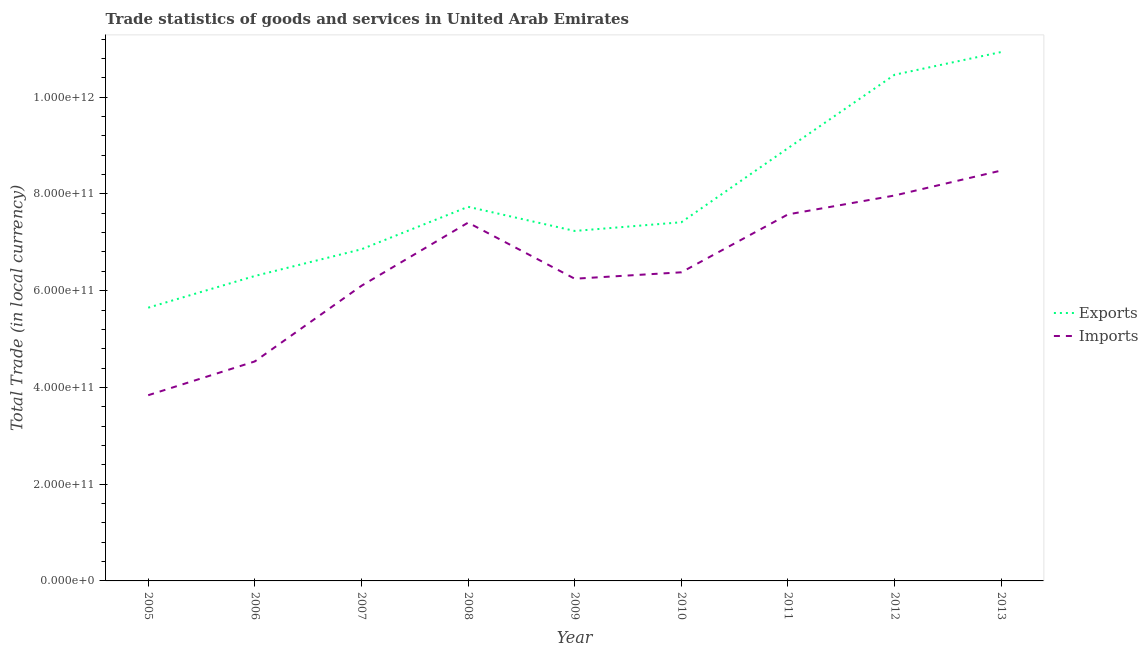What is the export of goods and services in 2005?
Offer a terse response. 5.65e+11. Across all years, what is the maximum imports of goods and services?
Provide a short and direct response. 8.48e+11. Across all years, what is the minimum export of goods and services?
Provide a short and direct response. 5.65e+11. In which year was the imports of goods and services maximum?
Provide a succinct answer. 2013. What is the total export of goods and services in the graph?
Your answer should be very brief. 7.15e+12. What is the difference between the imports of goods and services in 2010 and that in 2011?
Give a very brief answer. -1.20e+11. What is the difference between the imports of goods and services in 2013 and the export of goods and services in 2008?
Keep it short and to the point. 7.50e+1. What is the average export of goods and services per year?
Offer a terse response. 7.95e+11. In the year 2008, what is the difference between the imports of goods and services and export of goods and services?
Ensure brevity in your answer.  -3.27e+1. In how many years, is the imports of goods and services greater than 1080000000000 LCU?
Your response must be concise. 0. What is the ratio of the imports of goods and services in 2005 to that in 2008?
Provide a succinct answer. 0.52. What is the difference between the highest and the second highest imports of goods and services?
Provide a succinct answer. 5.16e+1. What is the difference between the highest and the lowest export of goods and services?
Make the answer very short. 5.29e+11. In how many years, is the imports of goods and services greater than the average imports of goods and services taken over all years?
Your response must be concise. 4. Is the imports of goods and services strictly less than the export of goods and services over the years?
Your answer should be very brief. Yes. How many lines are there?
Your answer should be very brief. 2. What is the difference between two consecutive major ticks on the Y-axis?
Offer a very short reply. 2.00e+11. Are the values on the major ticks of Y-axis written in scientific E-notation?
Ensure brevity in your answer.  Yes. Does the graph contain grids?
Provide a succinct answer. No. Where does the legend appear in the graph?
Ensure brevity in your answer.  Center right. What is the title of the graph?
Provide a succinct answer. Trade statistics of goods and services in United Arab Emirates. What is the label or title of the Y-axis?
Your response must be concise. Total Trade (in local currency). What is the Total Trade (in local currency) of Exports in 2005?
Offer a terse response. 5.65e+11. What is the Total Trade (in local currency) of Imports in 2005?
Your answer should be very brief. 3.84e+11. What is the Total Trade (in local currency) of Exports in 2006?
Provide a succinct answer. 6.30e+11. What is the Total Trade (in local currency) of Imports in 2006?
Your answer should be compact. 4.54e+11. What is the Total Trade (in local currency) of Exports in 2007?
Your answer should be compact. 6.86e+11. What is the Total Trade (in local currency) of Imports in 2007?
Provide a short and direct response. 6.10e+11. What is the Total Trade (in local currency) in Exports in 2008?
Offer a very short reply. 7.73e+11. What is the Total Trade (in local currency) in Imports in 2008?
Give a very brief answer. 7.41e+11. What is the Total Trade (in local currency) in Exports in 2009?
Provide a short and direct response. 7.24e+11. What is the Total Trade (in local currency) in Imports in 2009?
Offer a very short reply. 6.25e+11. What is the Total Trade (in local currency) of Exports in 2010?
Keep it short and to the point. 7.41e+11. What is the Total Trade (in local currency) in Imports in 2010?
Provide a short and direct response. 6.38e+11. What is the Total Trade (in local currency) in Exports in 2011?
Your answer should be very brief. 8.95e+11. What is the Total Trade (in local currency) of Imports in 2011?
Provide a succinct answer. 7.58e+11. What is the Total Trade (in local currency) in Exports in 2012?
Make the answer very short. 1.05e+12. What is the Total Trade (in local currency) in Imports in 2012?
Offer a very short reply. 7.97e+11. What is the Total Trade (in local currency) of Exports in 2013?
Provide a short and direct response. 1.09e+12. What is the Total Trade (in local currency) of Imports in 2013?
Give a very brief answer. 8.48e+11. Across all years, what is the maximum Total Trade (in local currency) of Exports?
Make the answer very short. 1.09e+12. Across all years, what is the maximum Total Trade (in local currency) in Imports?
Ensure brevity in your answer.  8.48e+11. Across all years, what is the minimum Total Trade (in local currency) of Exports?
Your response must be concise. 5.65e+11. Across all years, what is the minimum Total Trade (in local currency) in Imports?
Your answer should be compact. 3.84e+11. What is the total Total Trade (in local currency) in Exports in the graph?
Keep it short and to the point. 7.15e+12. What is the total Total Trade (in local currency) of Imports in the graph?
Provide a short and direct response. 5.85e+12. What is the difference between the Total Trade (in local currency) in Exports in 2005 and that in 2006?
Your response must be concise. -6.56e+1. What is the difference between the Total Trade (in local currency) in Imports in 2005 and that in 2006?
Make the answer very short. -6.99e+1. What is the difference between the Total Trade (in local currency) of Exports in 2005 and that in 2007?
Your answer should be compact. -1.21e+11. What is the difference between the Total Trade (in local currency) of Imports in 2005 and that in 2007?
Keep it short and to the point. -2.26e+11. What is the difference between the Total Trade (in local currency) of Exports in 2005 and that in 2008?
Offer a terse response. -2.09e+11. What is the difference between the Total Trade (in local currency) in Imports in 2005 and that in 2008?
Offer a very short reply. -3.57e+11. What is the difference between the Total Trade (in local currency) of Exports in 2005 and that in 2009?
Your response must be concise. -1.59e+11. What is the difference between the Total Trade (in local currency) in Imports in 2005 and that in 2009?
Offer a very short reply. -2.41e+11. What is the difference between the Total Trade (in local currency) of Exports in 2005 and that in 2010?
Provide a succinct answer. -1.77e+11. What is the difference between the Total Trade (in local currency) in Imports in 2005 and that in 2010?
Your response must be concise. -2.54e+11. What is the difference between the Total Trade (in local currency) in Exports in 2005 and that in 2011?
Give a very brief answer. -3.30e+11. What is the difference between the Total Trade (in local currency) in Imports in 2005 and that in 2011?
Your answer should be very brief. -3.74e+11. What is the difference between the Total Trade (in local currency) of Exports in 2005 and that in 2012?
Keep it short and to the point. -4.82e+11. What is the difference between the Total Trade (in local currency) of Imports in 2005 and that in 2012?
Your response must be concise. -4.13e+11. What is the difference between the Total Trade (in local currency) in Exports in 2005 and that in 2013?
Offer a very short reply. -5.29e+11. What is the difference between the Total Trade (in local currency) in Imports in 2005 and that in 2013?
Provide a succinct answer. -4.64e+11. What is the difference between the Total Trade (in local currency) in Exports in 2006 and that in 2007?
Ensure brevity in your answer.  -5.52e+1. What is the difference between the Total Trade (in local currency) in Imports in 2006 and that in 2007?
Your response must be concise. -1.56e+11. What is the difference between the Total Trade (in local currency) of Exports in 2006 and that in 2008?
Your answer should be compact. -1.43e+11. What is the difference between the Total Trade (in local currency) of Imports in 2006 and that in 2008?
Ensure brevity in your answer.  -2.87e+11. What is the difference between the Total Trade (in local currency) of Exports in 2006 and that in 2009?
Make the answer very short. -9.31e+1. What is the difference between the Total Trade (in local currency) in Imports in 2006 and that in 2009?
Your response must be concise. -1.71e+11. What is the difference between the Total Trade (in local currency) in Exports in 2006 and that in 2010?
Make the answer very short. -1.11e+11. What is the difference between the Total Trade (in local currency) in Imports in 2006 and that in 2010?
Offer a very short reply. -1.84e+11. What is the difference between the Total Trade (in local currency) in Exports in 2006 and that in 2011?
Your response must be concise. -2.64e+11. What is the difference between the Total Trade (in local currency) of Imports in 2006 and that in 2011?
Your answer should be very brief. -3.04e+11. What is the difference between the Total Trade (in local currency) of Exports in 2006 and that in 2012?
Your response must be concise. -4.16e+11. What is the difference between the Total Trade (in local currency) of Imports in 2006 and that in 2012?
Provide a short and direct response. -3.43e+11. What is the difference between the Total Trade (in local currency) of Exports in 2006 and that in 2013?
Make the answer very short. -4.63e+11. What is the difference between the Total Trade (in local currency) in Imports in 2006 and that in 2013?
Your answer should be very brief. -3.95e+11. What is the difference between the Total Trade (in local currency) in Exports in 2007 and that in 2008?
Give a very brief answer. -8.78e+1. What is the difference between the Total Trade (in local currency) in Imports in 2007 and that in 2008?
Your answer should be very brief. -1.31e+11. What is the difference between the Total Trade (in local currency) in Exports in 2007 and that in 2009?
Offer a very short reply. -3.79e+1. What is the difference between the Total Trade (in local currency) in Imports in 2007 and that in 2009?
Your response must be concise. -1.46e+1. What is the difference between the Total Trade (in local currency) of Exports in 2007 and that in 2010?
Ensure brevity in your answer.  -5.59e+1. What is the difference between the Total Trade (in local currency) of Imports in 2007 and that in 2010?
Keep it short and to the point. -2.79e+1. What is the difference between the Total Trade (in local currency) of Exports in 2007 and that in 2011?
Ensure brevity in your answer.  -2.09e+11. What is the difference between the Total Trade (in local currency) in Imports in 2007 and that in 2011?
Provide a succinct answer. -1.48e+11. What is the difference between the Total Trade (in local currency) of Exports in 2007 and that in 2012?
Ensure brevity in your answer.  -3.61e+11. What is the difference between the Total Trade (in local currency) of Imports in 2007 and that in 2012?
Keep it short and to the point. -1.87e+11. What is the difference between the Total Trade (in local currency) in Exports in 2007 and that in 2013?
Ensure brevity in your answer.  -4.08e+11. What is the difference between the Total Trade (in local currency) of Imports in 2007 and that in 2013?
Provide a short and direct response. -2.38e+11. What is the difference between the Total Trade (in local currency) of Exports in 2008 and that in 2009?
Ensure brevity in your answer.  4.99e+1. What is the difference between the Total Trade (in local currency) of Imports in 2008 and that in 2009?
Ensure brevity in your answer.  1.16e+11. What is the difference between the Total Trade (in local currency) of Exports in 2008 and that in 2010?
Offer a very short reply. 3.19e+1. What is the difference between the Total Trade (in local currency) of Imports in 2008 and that in 2010?
Provide a short and direct response. 1.03e+11. What is the difference between the Total Trade (in local currency) of Exports in 2008 and that in 2011?
Give a very brief answer. -1.21e+11. What is the difference between the Total Trade (in local currency) of Imports in 2008 and that in 2011?
Your answer should be compact. -1.70e+1. What is the difference between the Total Trade (in local currency) of Exports in 2008 and that in 2012?
Keep it short and to the point. -2.73e+11. What is the difference between the Total Trade (in local currency) in Imports in 2008 and that in 2012?
Provide a succinct answer. -5.61e+1. What is the difference between the Total Trade (in local currency) of Exports in 2008 and that in 2013?
Keep it short and to the point. -3.20e+11. What is the difference between the Total Trade (in local currency) in Imports in 2008 and that in 2013?
Your answer should be very brief. -1.08e+11. What is the difference between the Total Trade (in local currency) of Exports in 2009 and that in 2010?
Make the answer very short. -1.80e+1. What is the difference between the Total Trade (in local currency) in Imports in 2009 and that in 2010?
Make the answer very short. -1.33e+1. What is the difference between the Total Trade (in local currency) in Exports in 2009 and that in 2011?
Provide a short and direct response. -1.71e+11. What is the difference between the Total Trade (in local currency) of Imports in 2009 and that in 2011?
Give a very brief answer. -1.33e+11. What is the difference between the Total Trade (in local currency) in Exports in 2009 and that in 2012?
Your answer should be very brief. -3.23e+11. What is the difference between the Total Trade (in local currency) in Imports in 2009 and that in 2012?
Make the answer very short. -1.72e+11. What is the difference between the Total Trade (in local currency) in Exports in 2009 and that in 2013?
Your answer should be compact. -3.70e+11. What is the difference between the Total Trade (in local currency) in Imports in 2009 and that in 2013?
Your answer should be very brief. -2.24e+11. What is the difference between the Total Trade (in local currency) of Exports in 2010 and that in 2011?
Your answer should be compact. -1.53e+11. What is the difference between the Total Trade (in local currency) in Imports in 2010 and that in 2011?
Provide a short and direct response. -1.20e+11. What is the difference between the Total Trade (in local currency) in Exports in 2010 and that in 2012?
Provide a short and direct response. -3.05e+11. What is the difference between the Total Trade (in local currency) of Imports in 2010 and that in 2012?
Give a very brief answer. -1.59e+11. What is the difference between the Total Trade (in local currency) in Exports in 2010 and that in 2013?
Provide a succinct answer. -3.52e+11. What is the difference between the Total Trade (in local currency) in Imports in 2010 and that in 2013?
Make the answer very short. -2.10e+11. What is the difference between the Total Trade (in local currency) of Exports in 2011 and that in 2012?
Provide a succinct answer. -1.52e+11. What is the difference between the Total Trade (in local currency) in Imports in 2011 and that in 2012?
Ensure brevity in your answer.  -3.91e+1. What is the difference between the Total Trade (in local currency) of Exports in 2011 and that in 2013?
Provide a short and direct response. -1.99e+11. What is the difference between the Total Trade (in local currency) in Imports in 2011 and that in 2013?
Your answer should be very brief. -9.07e+1. What is the difference between the Total Trade (in local currency) in Exports in 2012 and that in 2013?
Give a very brief answer. -4.69e+1. What is the difference between the Total Trade (in local currency) in Imports in 2012 and that in 2013?
Keep it short and to the point. -5.16e+1. What is the difference between the Total Trade (in local currency) of Exports in 2005 and the Total Trade (in local currency) of Imports in 2006?
Provide a short and direct response. 1.11e+11. What is the difference between the Total Trade (in local currency) in Exports in 2005 and the Total Trade (in local currency) in Imports in 2007?
Offer a very short reply. -4.53e+1. What is the difference between the Total Trade (in local currency) of Exports in 2005 and the Total Trade (in local currency) of Imports in 2008?
Keep it short and to the point. -1.76e+11. What is the difference between the Total Trade (in local currency) in Exports in 2005 and the Total Trade (in local currency) in Imports in 2009?
Make the answer very short. -5.99e+1. What is the difference between the Total Trade (in local currency) in Exports in 2005 and the Total Trade (in local currency) in Imports in 2010?
Your answer should be very brief. -7.32e+1. What is the difference between the Total Trade (in local currency) of Exports in 2005 and the Total Trade (in local currency) of Imports in 2011?
Make the answer very short. -1.93e+11. What is the difference between the Total Trade (in local currency) in Exports in 2005 and the Total Trade (in local currency) in Imports in 2012?
Your answer should be compact. -2.32e+11. What is the difference between the Total Trade (in local currency) in Exports in 2005 and the Total Trade (in local currency) in Imports in 2013?
Provide a short and direct response. -2.84e+11. What is the difference between the Total Trade (in local currency) in Exports in 2006 and the Total Trade (in local currency) in Imports in 2007?
Your answer should be compact. 2.03e+1. What is the difference between the Total Trade (in local currency) of Exports in 2006 and the Total Trade (in local currency) of Imports in 2008?
Your answer should be very brief. -1.10e+11. What is the difference between the Total Trade (in local currency) in Exports in 2006 and the Total Trade (in local currency) in Imports in 2009?
Your response must be concise. 5.67e+09. What is the difference between the Total Trade (in local currency) of Exports in 2006 and the Total Trade (in local currency) of Imports in 2010?
Offer a very short reply. -7.59e+09. What is the difference between the Total Trade (in local currency) in Exports in 2006 and the Total Trade (in local currency) in Imports in 2011?
Keep it short and to the point. -1.27e+11. What is the difference between the Total Trade (in local currency) in Exports in 2006 and the Total Trade (in local currency) in Imports in 2012?
Give a very brief answer. -1.66e+11. What is the difference between the Total Trade (in local currency) of Exports in 2006 and the Total Trade (in local currency) of Imports in 2013?
Your answer should be very brief. -2.18e+11. What is the difference between the Total Trade (in local currency) of Exports in 2007 and the Total Trade (in local currency) of Imports in 2008?
Offer a terse response. -5.51e+1. What is the difference between the Total Trade (in local currency) in Exports in 2007 and the Total Trade (in local currency) in Imports in 2009?
Provide a succinct answer. 6.09e+1. What is the difference between the Total Trade (in local currency) of Exports in 2007 and the Total Trade (in local currency) of Imports in 2010?
Your answer should be very brief. 4.76e+1. What is the difference between the Total Trade (in local currency) in Exports in 2007 and the Total Trade (in local currency) in Imports in 2011?
Your answer should be very brief. -7.21e+1. What is the difference between the Total Trade (in local currency) in Exports in 2007 and the Total Trade (in local currency) in Imports in 2012?
Give a very brief answer. -1.11e+11. What is the difference between the Total Trade (in local currency) in Exports in 2007 and the Total Trade (in local currency) in Imports in 2013?
Keep it short and to the point. -1.63e+11. What is the difference between the Total Trade (in local currency) in Exports in 2008 and the Total Trade (in local currency) in Imports in 2009?
Your answer should be very brief. 1.49e+11. What is the difference between the Total Trade (in local currency) of Exports in 2008 and the Total Trade (in local currency) of Imports in 2010?
Your response must be concise. 1.35e+11. What is the difference between the Total Trade (in local currency) in Exports in 2008 and the Total Trade (in local currency) in Imports in 2011?
Your response must be concise. 1.57e+1. What is the difference between the Total Trade (in local currency) in Exports in 2008 and the Total Trade (in local currency) in Imports in 2012?
Your response must be concise. -2.34e+1. What is the difference between the Total Trade (in local currency) in Exports in 2008 and the Total Trade (in local currency) in Imports in 2013?
Ensure brevity in your answer.  -7.50e+1. What is the difference between the Total Trade (in local currency) of Exports in 2009 and the Total Trade (in local currency) of Imports in 2010?
Keep it short and to the point. 8.55e+1. What is the difference between the Total Trade (in local currency) in Exports in 2009 and the Total Trade (in local currency) in Imports in 2011?
Your answer should be very brief. -3.42e+1. What is the difference between the Total Trade (in local currency) of Exports in 2009 and the Total Trade (in local currency) of Imports in 2012?
Offer a very short reply. -7.33e+1. What is the difference between the Total Trade (in local currency) in Exports in 2009 and the Total Trade (in local currency) in Imports in 2013?
Your answer should be compact. -1.25e+11. What is the difference between the Total Trade (in local currency) in Exports in 2010 and the Total Trade (in local currency) in Imports in 2011?
Your response must be concise. -1.62e+1. What is the difference between the Total Trade (in local currency) of Exports in 2010 and the Total Trade (in local currency) of Imports in 2012?
Give a very brief answer. -5.53e+1. What is the difference between the Total Trade (in local currency) of Exports in 2010 and the Total Trade (in local currency) of Imports in 2013?
Give a very brief answer. -1.07e+11. What is the difference between the Total Trade (in local currency) in Exports in 2011 and the Total Trade (in local currency) in Imports in 2012?
Your answer should be compact. 9.78e+1. What is the difference between the Total Trade (in local currency) of Exports in 2011 and the Total Trade (in local currency) of Imports in 2013?
Provide a succinct answer. 4.63e+1. What is the difference between the Total Trade (in local currency) of Exports in 2012 and the Total Trade (in local currency) of Imports in 2013?
Keep it short and to the point. 1.98e+11. What is the average Total Trade (in local currency) in Exports per year?
Make the answer very short. 7.95e+11. What is the average Total Trade (in local currency) of Imports per year?
Provide a short and direct response. 6.50e+11. In the year 2005, what is the difference between the Total Trade (in local currency) in Exports and Total Trade (in local currency) in Imports?
Give a very brief answer. 1.81e+11. In the year 2006, what is the difference between the Total Trade (in local currency) of Exports and Total Trade (in local currency) of Imports?
Provide a short and direct response. 1.77e+11. In the year 2007, what is the difference between the Total Trade (in local currency) in Exports and Total Trade (in local currency) in Imports?
Give a very brief answer. 7.55e+1. In the year 2008, what is the difference between the Total Trade (in local currency) in Exports and Total Trade (in local currency) in Imports?
Your answer should be very brief. 3.27e+1. In the year 2009, what is the difference between the Total Trade (in local currency) of Exports and Total Trade (in local currency) of Imports?
Your answer should be compact. 9.88e+1. In the year 2010, what is the difference between the Total Trade (in local currency) of Exports and Total Trade (in local currency) of Imports?
Give a very brief answer. 1.03e+11. In the year 2011, what is the difference between the Total Trade (in local currency) in Exports and Total Trade (in local currency) in Imports?
Your answer should be compact. 1.37e+11. In the year 2012, what is the difference between the Total Trade (in local currency) in Exports and Total Trade (in local currency) in Imports?
Ensure brevity in your answer.  2.50e+11. In the year 2013, what is the difference between the Total Trade (in local currency) in Exports and Total Trade (in local currency) in Imports?
Your response must be concise. 2.45e+11. What is the ratio of the Total Trade (in local currency) of Exports in 2005 to that in 2006?
Keep it short and to the point. 0.9. What is the ratio of the Total Trade (in local currency) in Imports in 2005 to that in 2006?
Give a very brief answer. 0.85. What is the ratio of the Total Trade (in local currency) in Exports in 2005 to that in 2007?
Give a very brief answer. 0.82. What is the ratio of the Total Trade (in local currency) of Imports in 2005 to that in 2007?
Your response must be concise. 0.63. What is the ratio of the Total Trade (in local currency) of Exports in 2005 to that in 2008?
Your response must be concise. 0.73. What is the ratio of the Total Trade (in local currency) of Imports in 2005 to that in 2008?
Make the answer very short. 0.52. What is the ratio of the Total Trade (in local currency) of Exports in 2005 to that in 2009?
Provide a succinct answer. 0.78. What is the ratio of the Total Trade (in local currency) in Imports in 2005 to that in 2009?
Your answer should be very brief. 0.61. What is the ratio of the Total Trade (in local currency) of Exports in 2005 to that in 2010?
Keep it short and to the point. 0.76. What is the ratio of the Total Trade (in local currency) of Imports in 2005 to that in 2010?
Give a very brief answer. 0.6. What is the ratio of the Total Trade (in local currency) in Exports in 2005 to that in 2011?
Your answer should be compact. 0.63. What is the ratio of the Total Trade (in local currency) in Imports in 2005 to that in 2011?
Provide a succinct answer. 0.51. What is the ratio of the Total Trade (in local currency) of Exports in 2005 to that in 2012?
Ensure brevity in your answer.  0.54. What is the ratio of the Total Trade (in local currency) in Imports in 2005 to that in 2012?
Provide a succinct answer. 0.48. What is the ratio of the Total Trade (in local currency) in Exports in 2005 to that in 2013?
Your response must be concise. 0.52. What is the ratio of the Total Trade (in local currency) in Imports in 2005 to that in 2013?
Your answer should be compact. 0.45. What is the ratio of the Total Trade (in local currency) in Exports in 2006 to that in 2007?
Make the answer very short. 0.92. What is the ratio of the Total Trade (in local currency) of Imports in 2006 to that in 2007?
Your response must be concise. 0.74. What is the ratio of the Total Trade (in local currency) in Exports in 2006 to that in 2008?
Offer a terse response. 0.82. What is the ratio of the Total Trade (in local currency) of Imports in 2006 to that in 2008?
Your response must be concise. 0.61. What is the ratio of the Total Trade (in local currency) of Exports in 2006 to that in 2009?
Provide a succinct answer. 0.87. What is the ratio of the Total Trade (in local currency) in Imports in 2006 to that in 2009?
Offer a terse response. 0.73. What is the ratio of the Total Trade (in local currency) of Exports in 2006 to that in 2010?
Provide a succinct answer. 0.85. What is the ratio of the Total Trade (in local currency) of Imports in 2006 to that in 2010?
Your answer should be very brief. 0.71. What is the ratio of the Total Trade (in local currency) of Exports in 2006 to that in 2011?
Give a very brief answer. 0.7. What is the ratio of the Total Trade (in local currency) of Imports in 2006 to that in 2011?
Your answer should be compact. 0.6. What is the ratio of the Total Trade (in local currency) of Exports in 2006 to that in 2012?
Offer a terse response. 0.6. What is the ratio of the Total Trade (in local currency) of Imports in 2006 to that in 2012?
Provide a short and direct response. 0.57. What is the ratio of the Total Trade (in local currency) of Exports in 2006 to that in 2013?
Ensure brevity in your answer.  0.58. What is the ratio of the Total Trade (in local currency) of Imports in 2006 to that in 2013?
Ensure brevity in your answer.  0.53. What is the ratio of the Total Trade (in local currency) of Exports in 2007 to that in 2008?
Make the answer very short. 0.89. What is the ratio of the Total Trade (in local currency) in Imports in 2007 to that in 2008?
Your response must be concise. 0.82. What is the ratio of the Total Trade (in local currency) of Exports in 2007 to that in 2009?
Offer a terse response. 0.95. What is the ratio of the Total Trade (in local currency) in Imports in 2007 to that in 2009?
Offer a very short reply. 0.98. What is the ratio of the Total Trade (in local currency) in Exports in 2007 to that in 2010?
Keep it short and to the point. 0.92. What is the ratio of the Total Trade (in local currency) of Imports in 2007 to that in 2010?
Ensure brevity in your answer.  0.96. What is the ratio of the Total Trade (in local currency) of Exports in 2007 to that in 2011?
Make the answer very short. 0.77. What is the ratio of the Total Trade (in local currency) in Imports in 2007 to that in 2011?
Provide a short and direct response. 0.81. What is the ratio of the Total Trade (in local currency) in Exports in 2007 to that in 2012?
Your response must be concise. 0.66. What is the ratio of the Total Trade (in local currency) of Imports in 2007 to that in 2012?
Ensure brevity in your answer.  0.77. What is the ratio of the Total Trade (in local currency) of Exports in 2007 to that in 2013?
Ensure brevity in your answer.  0.63. What is the ratio of the Total Trade (in local currency) in Imports in 2007 to that in 2013?
Provide a succinct answer. 0.72. What is the ratio of the Total Trade (in local currency) of Exports in 2008 to that in 2009?
Keep it short and to the point. 1.07. What is the ratio of the Total Trade (in local currency) of Imports in 2008 to that in 2009?
Offer a very short reply. 1.19. What is the ratio of the Total Trade (in local currency) in Exports in 2008 to that in 2010?
Give a very brief answer. 1.04. What is the ratio of the Total Trade (in local currency) of Imports in 2008 to that in 2010?
Your answer should be very brief. 1.16. What is the ratio of the Total Trade (in local currency) in Exports in 2008 to that in 2011?
Your answer should be compact. 0.86. What is the ratio of the Total Trade (in local currency) of Imports in 2008 to that in 2011?
Keep it short and to the point. 0.98. What is the ratio of the Total Trade (in local currency) in Exports in 2008 to that in 2012?
Your answer should be compact. 0.74. What is the ratio of the Total Trade (in local currency) of Imports in 2008 to that in 2012?
Ensure brevity in your answer.  0.93. What is the ratio of the Total Trade (in local currency) in Exports in 2008 to that in 2013?
Offer a terse response. 0.71. What is the ratio of the Total Trade (in local currency) of Imports in 2008 to that in 2013?
Give a very brief answer. 0.87. What is the ratio of the Total Trade (in local currency) of Exports in 2009 to that in 2010?
Ensure brevity in your answer.  0.98. What is the ratio of the Total Trade (in local currency) of Imports in 2009 to that in 2010?
Make the answer very short. 0.98. What is the ratio of the Total Trade (in local currency) of Exports in 2009 to that in 2011?
Your answer should be compact. 0.81. What is the ratio of the Total Trade (in local currency) of Imports in 2009 to that in 2011?
Your answer should be compact. 0.82. What is the ratio of the Total Trade (in local currency) in Exports in 2009 to that in 2012?
Offer a terse response. 0.69. What is the ratio of the Total Trade (in local currency) in Imports in 2009 to that in 2012?
Your answer should be compact. 0.78. What is the ratio of the Total Trade (in local currency) in Exports in 2009 to that in 2013?
Provide a succinct answer. 0.66. What is the ratio of the Total Trade (in local currency) in Imports in 2009 to that in 2013?
Offer a very short reply. 0.74. What is the ratio of the Total Trade (in local currency) in Exports in 2010 to that in 2011?
Provide a succinct answer. 0.83. What is the ratio of the Total Trade (in local currency) in Imports in 2010 to that in 2011?
Keep it short and to the point. 0.84. What is the ratio of the Total Trade (in local currency) of Exports in 2010 to that in 2012?
Ensure brevity in your answer.  0.71. What is the ratio of the Total Trade (in local currency) of Imports in 2010 to that in 2012?
Ensure brevity in your answer.  0.8. What is the ratio of the Total Trade (in local currency) in Exports in 2010 to that in 2013?
Keep it short and to the point. 0.68. What is the ratio of the Total Trade (in local currency) in Imports in 2010 to that in 2013?
Provide a short and direct response. 0.75. What is the ratio of the Total Trade (in local currency) in Exports in 2011 to that in 2012?
Your answer should be compact. 0.85. What is the ratio of the Total Trade (in local currency) in Imports in 2011 to that in 2012?
Your answer should be compact. 0.95. What is the ratio of the Total Trade (in local currency) in Exports in 2011 to that in 2013?
Ensure brevity in your answer.  0.82. What is the ratio of the Total Trade (in local currency) in Imports in 2011 to that in 2013?
Provide a succinct answer. 0.89. What is the ratio of the Total Trade (in local currency) of Exports in 2012 to that in 2013?
Provide a succinct answer. 0.96. What is the ratio of the Total Trade (in local currency) of Imports in 2012 to that in 2013?
Provide a succinct answer. 0.94. What is the difference between the highest and the second highest Total Trade (in local currency) of Exports?
Give a very brief answer. 4.69e+1. What is the difference between the highest and the second highest Total Trade (in local currency) in Imports?
Provide a succinct answer. 5.16e+1. What is the difference between the highest and the lowest Total Trade (in local currency) of Exports?
Your answer should be compact. 5.29e+11. What is the difference between the highest and the lowest Total Trade (in local currency) in Imports?
Make the answer very short. 4.64e+11. 